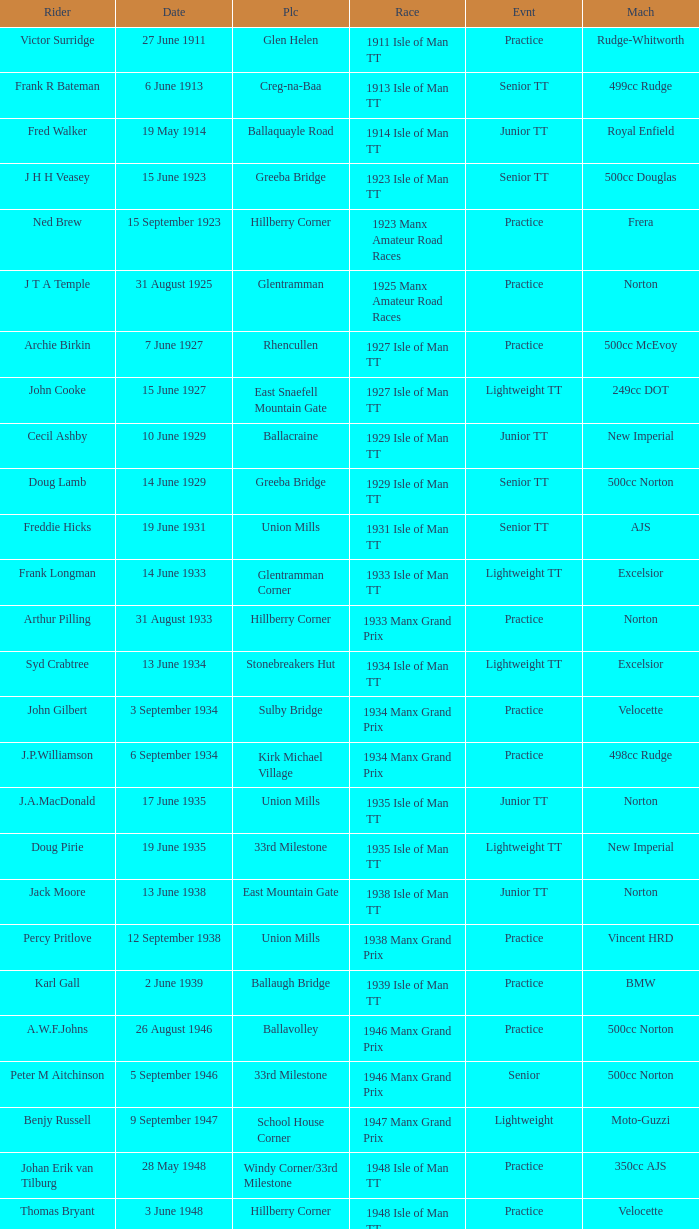What machine did Kenneth E. Herbert ride? 499cc Norton. 